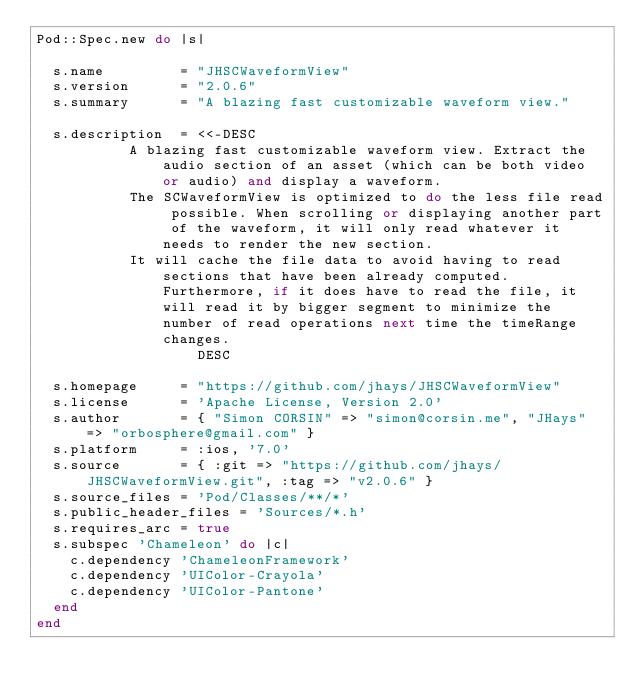Convert code to text. <code><loc_0><loc_0><loc_500><loc_500><_Ruby_>Pod::Spec.new do |s|

  s.name         = "JHSCWaveformView"
  s.version      = "2.0.6"
  s.summary      = "A blazing fast customizable waveform view."

  s.description  = <<-DESC
		   A blazing fast customizable waveform view. Extract the audio section of an asset (which can be both video or audio) and display a waveform.
		   The SCWaveformView is optimized to do the less file read possible. When scrolling or displaying another part of the waveform, it will only read whatever it needs to render the new section.
		   It will cache the file data to avoid having to read sections that have been already computed. Furthermore, if it does have to read the file, it will read it by bigger segment to minimize the number of read operations next time the timeRange changes.
                   DESC

  s.homepage     = "https://github.com/jhays/JHSCWaveformView"
  s.license      = 'Apache License, Version 2.0'
  s.author       = { "Simon CORSIN" => "simon@corsin.me", "JHays" => "orbosphere@gmail.com" }
  s.platform     = :ios, '7.0'
  s.source       = { :git => "https://github.com/jhays/JHSCWaveformView.git", :tag => "v2.0.6" }
  s.source_files = 'Pod/Classes/**/*'
  s.public_header_files = 'Sources/*.h'
  s.requires_arc = true
  s.subspec 'Chameleon' do |c|
    c.dependency 'ChameleonFramework'
    c.dependency 'UIColor-Crayola'
    c.dependency 'UIColor-Pantone'
  end
end
</code> 